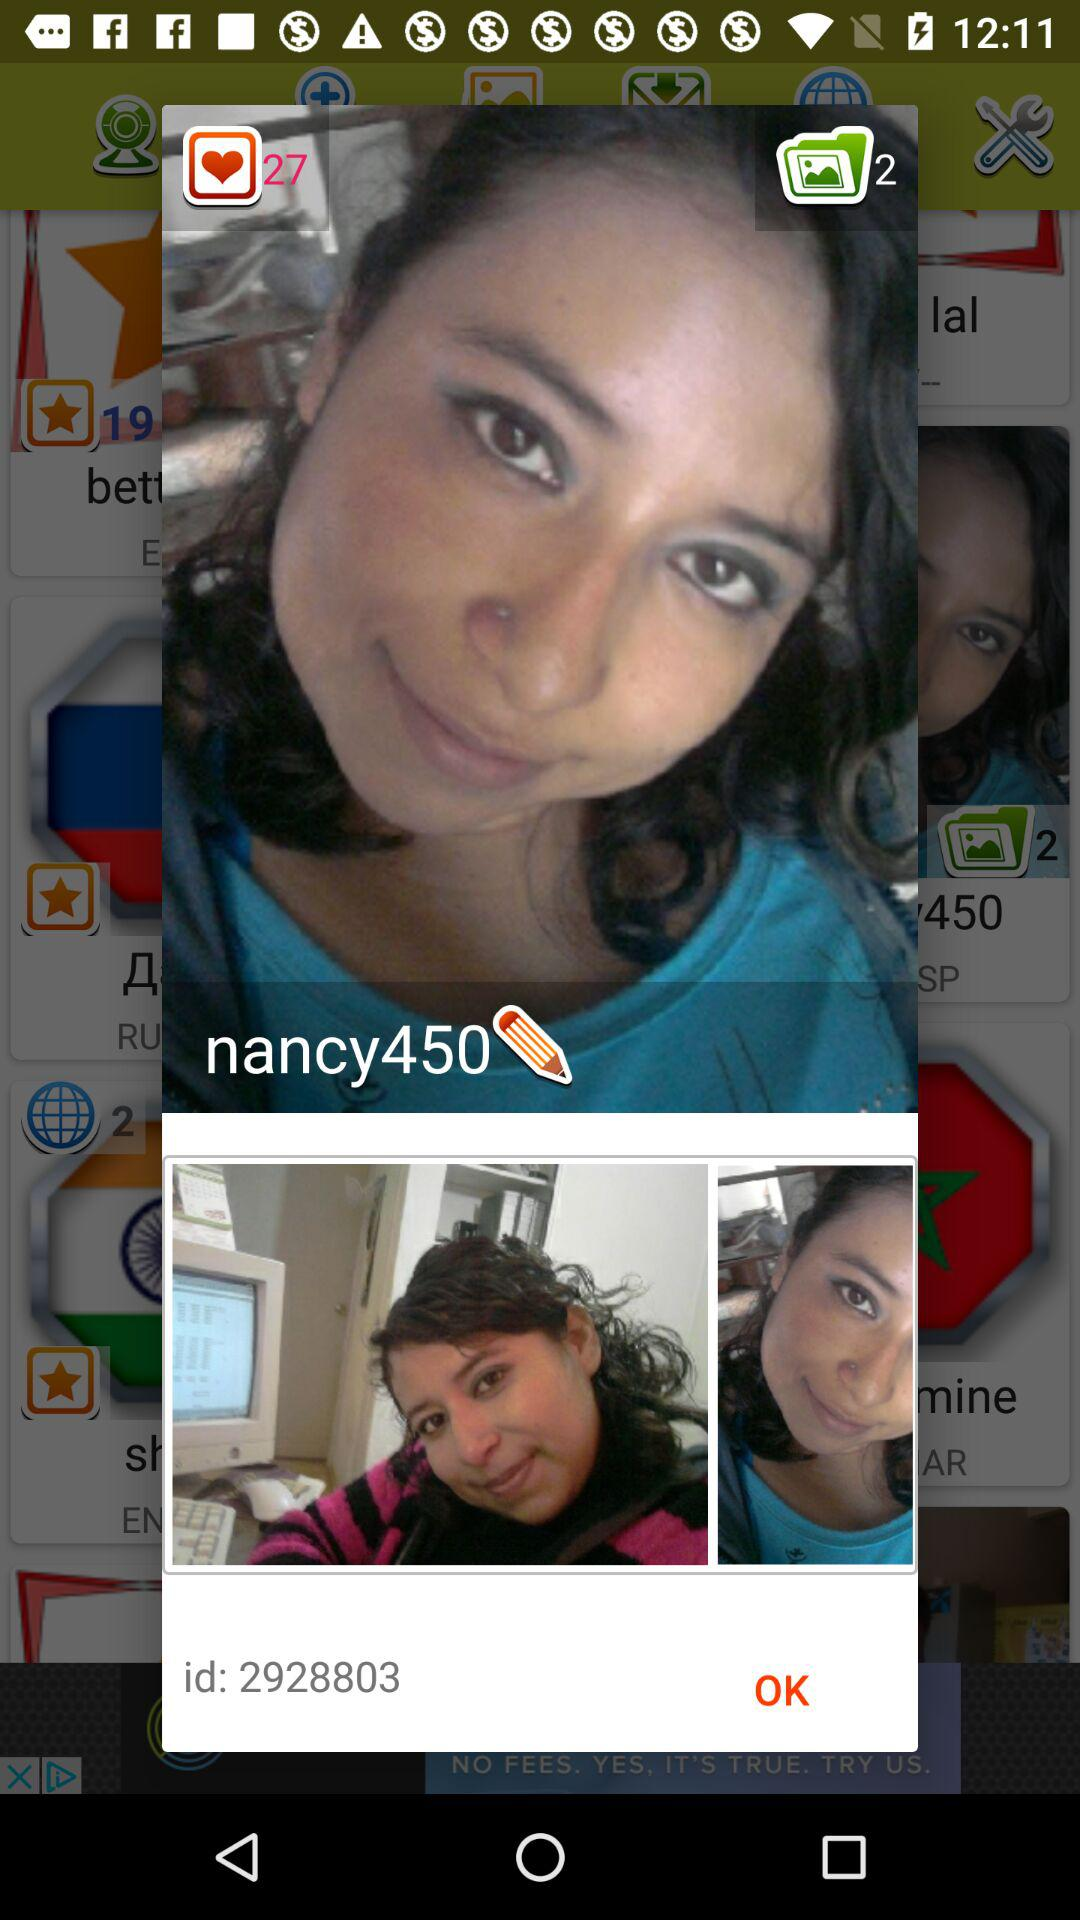How many likes does the user have? The user has 27 likes. 